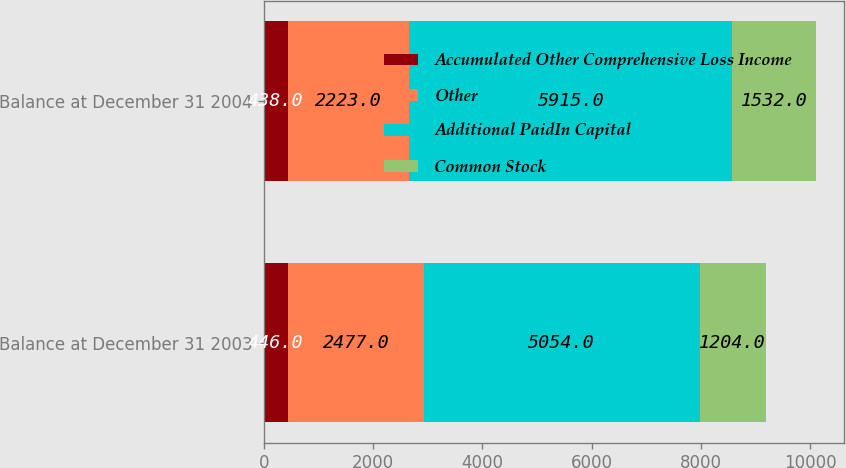Convert chart. <chart><loc_0><loc_0><loc_500><loc_500><stacked_bar_chart><ecel><fcel>Balance at December 31 2003<fcel>Balance at December 31 2004<nl><fcel>Accumulated Other Comprehensive Loss Income<fcel>446<fcel>438<nl><fcel>Other<fcel>2477<fcel>2223<nl><fcel>Additional PaidIn Capital<fcel>5054<fcel>5915<nl><fcel>Common Stock<fcel>1204<fcel>1532<nl></chart> 